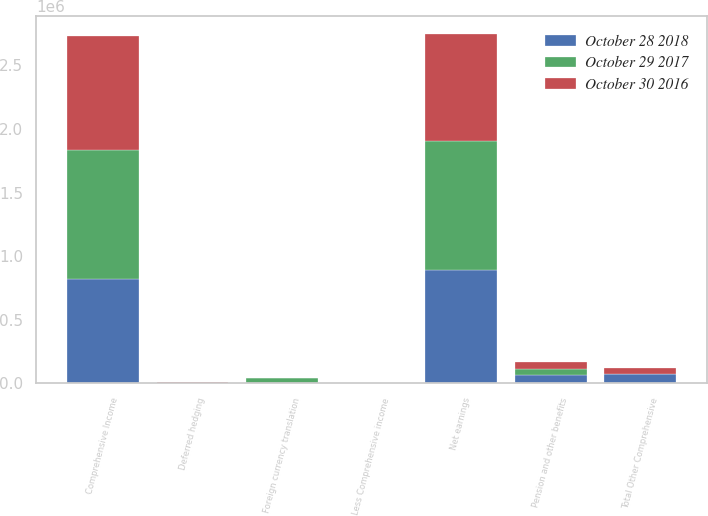Convert chart to OTSL. <chart><loc_0><loc_0><loc_500><loc_500><stacked_bar_chart><ecel><fcel>Net earnings<fcel>Foreign currency translation<fcel>Pension and other benefits<fcel>Deferred hedging<fcel>Total Other Comprehensive<fcel>Comprehensive Income<fcel>Less Comprehensive income<nl><fcel>October 29 2017<fcel>1.01258e+06<fcel>38233<fcel>44862<fcel>2277<fcel>4352<fcel>1.01672e+06<fcel>217<nl><fcel>October 30 2016<fcel>847103<fcel>1335<fcel>54077<fcel>4492<fcel>48250<fcel>894963<fcel>390<nl><fcel>October 28 2018<fcel>890517<fcel>6718<fcel>69286<fcel>5109<fcel>70895<fcel>819417<fcel>205<nl></chart> 